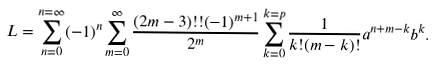<formula> <loc_0><loc_0><loc_500><loc_500>L = \sum _ { n = 0 } ^ { n = \infty } ( - 1 ) ^ { n } \sum _ { m = 0 } ^ { \infty } \frac { ( 2 m - 3 ) ! ! ( - 1 ) ^ { m + 1 } } { 2 ^ { m } } \sum _ { k = 0 } ^ { k = p } \frac { 1 } { k ! ( m - k ) ! } a ^ { n + m - k } b ^ { k } .</formula> 